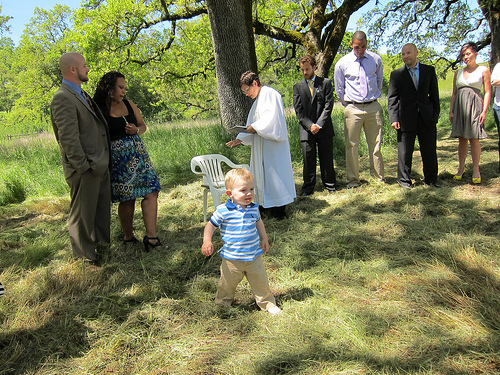<image>
Is the baby on the grass? Yes. Looking at the image, I can see the baby is positioned on top of the grass, with the grass providing support. 